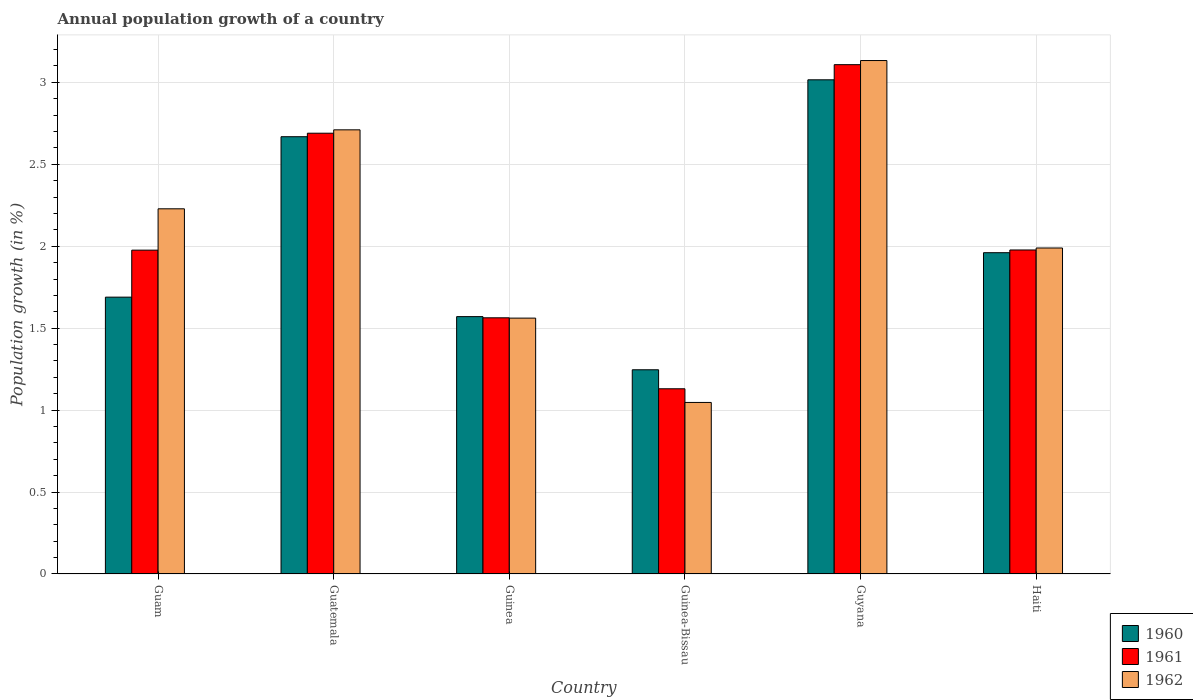How many different coloured bars are there?
Provide a short and direct response. 3. How many bars are there on the 2nd tick from the right?
Your response must be concise. 3. What is the label of the 5th group of bars from the left?
Provide a succinct answer. Guyana. In how many cases, is the number of bars for a given country not equal to the number of legend labels?
Your answer should be very brief. 0. What is the annual population growth in 1960 in Guinea?
Provide a short and direct response. 1.57. Across all countries, what is the maximum annual population growth in 1960?
Provide a short and direct response. 3.02. Across all countries, what is the minimum annual population growth in 1960?
Your response must be concise. 1.25. In which country was the annual population growth in 1962 maximum?
Offer a terse response. Guyana. In which country was the annual population growth in 1960 minimum?
Make the answer very short. Guinea-Bissau. What is the total annual population growth in 1960 in the graph?
Your answer should be compact. 12.15. What is the difference between the annual population growth in 1960 in Guam and that in Guyana?
Your response must be concise. -1.33. What is the difference between the annual population growth in 1962 in Guinea and the annual population growth in 1961 in Guyana?
Make the answer very short. -1.55. What is the average annual population growth in 1961 per country?
Give a very brief answer. 2.07. What is the difference between the annual population growth of/in 1962 and annual population growth of/in 1961 in Guatemala?
Provide a short and direct response. 0.02. What is the ratio of the annual population growth in 1962 in Guam to that in Haiti?
Offer a very short reply. 1.12. What is the difference between the highest and the second highest annual population growth in 1961?
Offer a terse response. -0.71. What is the difference between the highest and the lowest annual population growth in 1962?
Offer a terse response. 2.09. In how many countries, is the annual population growth in 1962 greater than the average annual population growth in 1962 taken over all countries?
Your answer should be compact. 3. What does the 3rd bar from the left in Guinea represents?
Make the answer very short. 1962. Is it the case that in every country, the sum of the annual population growth in 1961 and annual population growth in 1960 is greater than the annual population growth in 1962?
Ensure brevity in your answer.  Yes. What is the title of the graph?
Your answer should be very brief. Annual population growth of a country. What is the label or title of the X-axis?
Keep it short and to the point. Country. What is the label or title of the Y-axis?
Your response must be concise. Population growth (in %). What is the Population growth (in %) of 1960 in Guam?
Ensure brevity in your answer.  1.69. What is the Population growth (in %) in 1961 in Guam?
Keep it short and to the point. 1.98. What is the Population growth (in %) of 1962 in Guam?
Ensure brevity in your answer.  2.23. What is the Population growth (in %) in 1960 in Guatemala?
Offer a terse response. 2.67. What is the Population growth (in %) in 1961 in Guatemala?
Keep it short and to the point. 2.69. What is the Population growth (in %) of 1962 in Guatemala?
Your answer should be compact. 2.71. What is the Population growth (in %) in 1960 in Guinea?
Provide a short and direct response. 1.57. What is the Population growth (in %) of 1961 in Guinea?
Your answer should be compact. 1.56. What is the Population growth (in %) of 1962 in Guinea?
Offer a terse response. 1.56. What is the Population growth (in %) of 1960 in Guinea-Bissau?
Your response must be concise. 1.25. What is the Population growth (in %) of 1961 in Guinea-Bissau?
Give a very brief answer. 1.13. What is the Population growth (in %) of 1962 in Guinea-Bissau?
Provide a short and direct response. 1.05. What is the Population growth (in %) of 1960 in Guyana?
Your response must be concise. 3.02. What is the Population growth (in %) in 1961 in Guyana?
Ensure brevity in your answer.  3.11. What is the Population growth (in %) in 1962 in Guyana?
Your answer should be very brief. 3.13. What is the Population growth (in %) of 1960 in Haiti?
Make the answer very short. 1.96. What is the Population growth (in %) of 1961 in Haiti?
Provide a short and direct response. 1.98. What is the Population growth (in %) in 1962 in Haiti?
Give a very brief answer. 1.99. Across all countries, what is the maximum Population growth (in %) in 1960?
Provide a short and direct response. 3.02. Across all countries, what is the maximum Population growth (in %) of 1961?
Offer a terse response. 3.11. Across all countries, what is the maximum Population growth (in %) in 1962?
Provide a succinct answer. 3.13. Across all countries, what is the minimum Population growth (in %) of 1960?
Provide a succinct answer. 1.25. Across all countries, what is the minimum Population growth (in %) of 1961?
Give a very brief answer. 1.13. Across all countries, what is the minimum Population growth (in %) of 1962?
Your answer should be compact. 1.05. What is the total Population growth (in %) of 1960 in the graph?
Ensure brevity in your answer.  12.15. What is the total Population growth (in %) in 1961 in the graph?
Offer a very short reply. 12.44. What is the total Population growth (in %) in 1962 in the graph?
Keep it short and to the point. 12.67. What is the difference between the Population growth (in %) in 1960 in Guam and that in Guatemala?
Offer a very short reply. -0.98. What is the difference between the Population growth (in %) of 1961 in Guam and that in Guatemala?
Provide a succinct answer. -0.71. What is the difference between the Population growth (in %) of 1962 in Guam and that in Guatemala?
Your answer should be compact. -0.48. What is the difference between the Population growth (in %) in 1960 in Guam and that in Guinea?
Your answer should be compact. 0.12. What is the difference between the Population growth (in %) in 1961 in Guam and that in Guinea?
Your answer should be very brief. 0.41. What is the difference between the Population growth (in %) in 1962 in Guam and that in Guinea?
Offer a terse response. 0.67. What is the difference between the Population growth (in %) in 1960 in Guam and that in Guinea-Bissau?
Ensure brevity in your answer.  0.44. What is the difference between the Population growth (in %) in 1961 in Guam and that in Guinea-Bissau?
Keep it short and to the point. 0.85. What is the difference between the Population growth (in %) in 1962 in Guam and that in Guinea-Bissau?
Ensure brevity in your answer.  1.18. What is the difference between the Population growth (in %) in 1960 in Guam and that in Guyana?
Make the answer very short. -1.33. What is the difference between the Population growth (in %) of 1961 in Guam and that in Guyana?
Provide a short and direct response. -1.13. What is the difference between the Population growth (in %) of 1962 in Guam and that in Guyana?
Provide a short and direct response. -0.9. What is the difference between the Population growth (in %) in 1960 in Guam and that in Haiti?
Give a very brief answer. -0.27. What is the difference between the Population growth (in %) of 1961 in Guam and that in Haiti?
Your answer should be compact. -0. What is the difference between the Population growth (in %) in 1962 in Guam and that in Haiti?
Make the answer very short. 0.24. What is the difference between the Population growth (in %) in 1960 in Guatemala and that in Guinea?
Provide a succinct answer. 1.1. What is the difference between the Population growth (in %) in 1961 in Guatemala and that in Guinea?
Make the answer very short. 1.13. What is the difference between the Population growth (in %) of 1962 in Guatemala and that in Guinea?
Keep it short and to the point. 1.15. What is the difference between the Population growth (in %) of 1960 in Guatemala and that in Guinea-Bissau?
Make the answer very short. 1.42. What is the difference between the Population growth (in %) of 1961 in Guatemala and that in Guinea-Bissau?
Your answer should be compact. 1.56. What is the difference between the Population growth (in %) of 1962 in Guatemala and that in Guinea-Bissau?
Your answer should be compact. 1.66. What is the difference between the Population growth (in %) of 1960 in Guatemala and that in Guyana?
Keep it short and to the point. -0.35. What is the difference between the Population growth (in %) of 1961 in Guatemala and that in Guyana?
Ensure brevity in your answer.  -0.42. What is the difference between the Population growth (in %) in 1962 in Guatemala and that in Guyana?
Offer a very short reply. -0.42. What is the difference between the Population growth (in %) of 1960 in Guatemala and that in Haiti?
Provide a short and direct response. 0.71. What is the difference between the Population growth (in %) of 1961 in Guatemala and that in Haiti?
Ensure brevity in your answer.  0.71. What is the difference between the Population growth (in %) of 1962 in Guatemala and that in Haiti?
Your answer should be compact. 0.72. What is the difference between the Population growth (in %) in 1960 in Guinea and that in Guinea-Bissau?
Your answer should be very brief. 0.32. What is the difference between the Population growth (in %) of 1961 in Guinea and that in Guinea-Bissau?
Offer a terse response. 0.43. What is the difference between the Population growth (in %) of 1962 in Guinea and that in Guinea-Bissau?
Ensure brevity in your answer.  0.51. What is the difference between the Population growth (in %) of 1960 in Guinea and that in Guyana?
Give a very brief answer. -1.45. What is the difference between the Population growth (in %) of 1961 in Guinea and that in Guyana?
Ensure brevity in your answer.  -1.54. What is the difference between the Population growth (in %) in 1962 in Guinea and that in Guyana?
Give a very brief answer. -1.57. What is the difference between the Population growth (in %) of 1960 in Guinea and that in Haiti?
Provide a succinct answer. -0.39. What is the difference between the Population growth (in %) in 1961 in Guinea and that in Haiti?
Offer a very short reply. -0.41. What is the difference between the Population growth (in %) of 1962 in Guinea and that in Haiti?
Provide a succinct answer. -0.43. What is the difference between the Population growth (in %) of 1960 in Guinea-Bissau and that in Guyana?
Your answer should be compact. -1.77. What is the difference between the Population growth (in %) of 1961 in Guinea-Bissau and that in Guyana?
Provide a short and direct response. -1.98. What is the difference between the Population growth (in %) of 1962 in Guinea-Bissau and that in Guyana?
Keep it short and to the point. -2.09. What is the difference between the Population growth (in %) of 1960 in Guinea-Bissau and that in Haiti?
Offer a very short reply. -0.71. What is the difference between the Population growth (in %) in 1961 in Guinea-Bissau and that in Haiti?
Your response must be concise. -0.85. What is the difference between the Population growth (in %) in 1962 in Guinea-Bissau and that in Haiti?
Make the answer very short. -0.94. What is the difference between the Population growth (in %) in 1960 in Guyana and that in Haiti?
Your answer should be very brief. 1.06. What is the difference between the Population growth (in %) of 1961 in Guyana and that in Haiti?
Your response must be concise. 1.13. What is the difference between the Population growth (in %) of 1962 in Guyana and that in Haiti?
Your answer should be very brief. 1.14. What is the difference between the Population growth (in %) of 1960 in Guam and the Population growth (in %) of 1961 in Guatemala?
Your response must be concise. -1. What is the difference between the Population growth (in %) of 1960 in Guam and the Population growth (in %) of 1962 in Guatemala?
Your answer should be very brief. -1.02. What is the difference between the Population growth (in %) of 1961 in Guam and the Population growth (in %) of 1962 in Guatemala?
Your answer should be very brief. -0.73. What is the difference between the Population growth (in %) in 1960 in Guam and the Population growth (in %) in 1961 in Guinea?
Offer a very short reply. 0.13. What is the difference between the Population growth (in %) in 1960 in Guam and the Population growth (in %) in 1962 in Guinea?
Ensure brevity in your answer.  0.13. What is the difference between the Population growth (in %) in 1961 in Guam and the Population growth (in %) in 1962 in Guinea?
Your answer should be compact. 0.41. What is the difference between the Population growth (in %) of 1960 in Guam and the Population growth (in %) of 1961 in Guinea-Bissau?
Make the answer very short. 0.56. What is the difference between the Population growth (in %) in 1960 in Guam and the Population growth (in %) in 1962 in Guinea-Bissau?
Give a very brief answer. 0.64. What is the difference between the Population growth (in %) in 1961 in Guam and the Population growth (in %) in 1962 in Guinea-Bissau?
Give a very brief answer. 0.93. What is the difference between the Population growth (in %) of 1960 in Guam and the Population growth (in %) of 1961 in Guyana?
Provide a succinct answer. -1.42. What is the difference between the Population growth (in %) of 1960 in Guam and the Population growth (in %) of 1962 in Guyana?
Offer a very short reply. -1.44. What is the difference between the Population growth (in %) of 1961 in Guam and the Population growth (in %) of 1962 in Guyana?
Your answer should be compact. -1.16. What is the difference between the Population growth (in %) of 1960 in Guam and the Population growth (in %) of 1961 in Haiti?
Provide a short and direct response. -0.29. What is the difference between the Population growth (in %) of 1960 in Guam and the Population growth (in %) of 1962 in Haiti?
Keep it short and to the point. -0.3. What is the difference between the Population growth (in %) in 1961 in Guam and the Population growth (in %) in 1962 in Haiti?
Make the answer very short. -0.01. What is the difference between the Population growth (in %) of 1960 in Guatemala and the Population growth (in %) of 1961 in Guinea?
Provide a succinct answer. 1.11. What is the difference between the Population growth (in %) in 1960 in Guatemala and the Population growth (in %) in 1962 in Guinea?
Provide a succinct answer. 1.11. What is the difference between the Population growth (in %) in 1961 in Guatemala and the Population growth (in %) in 1962 in Guinea?
Your answer should be compact. 1.13. What is the difference between the Population growth (in %) of 1960 in Guatemala and the Population growth (in %) of 1961 in Guinea-Bissau?
Your answer should be very brief. 1.54. What is the difference between the Population growth (in %) in 1960 in Guatemala and the Population growth (in %) in 1962 in Guinea-Bissau?
Give a very brief answer. 1.62. What is the difference between the Population growth (in %) in 1961 in Guatemala and the Population growth (in %) in 1962 in Guinea-Bissau?
Make the answer very short. 1.64. What is the difference between the Population growth (in %) in 1960 in Guatemala and the Population growth (in %) in 1961 in Guyana?
Provide a short and direct response. -0.44. What is the difference between the Population growth (in %) in 1960 in Guatemala and the Population growth (in %) in 1962 in Guyana?
Offer a very short reply. -0.46. What is the difference between the Population growth (in %) of 1961 in Guatemala and the Population growth (in %) of 1962 in Guyana?
Provide a short and direct response. -0.44. What is the difference between the Population growth (in %) in 1960 in Guatemala and the Population growth (in %) in 1961 in Haiti?
Your answer should be very brief. 0.69. What is the difference between the Population growth (in %) in 1960 in Guatemala and the Population growth (in %) in 1962 in Haiti?
Your answer should be very brief. 0.68. What is the difference between the Population growth (in %) of 1961 in Guatemala and the Population growth (in %) of 1962 in Haiti?
Keep it short and to the point. 0.7. What is the difference between the Population growth (in %) in 1960 in Guinea and the Population growth (in %) in 1961 in Guinea-Bissau?
Provide a short and direct response. 0.44. What is the difference between the Population growth (in %) in 1960 in Guinea and the Population growth (in %) in 1962 in Guinea-Bissau?
Provide a short and direct response. 0.52. What is the difference between the Population growth (in %) of 1961 in Guinea and the Population growth (in %) of 1962 in Guinea-Bissau?
Ensure brevity in your answer.  0.52. What is the difference between the Population growth (in %) in 1960 in Guinea and the Population growth (in %) in 1961 in Guyana?
Provide a succinct answer. -1.54. What is the difference between the Population growth (in %) of 1960 in Guinea and the Population growth (in %) of 1962 in Guyana?
Ensure brevity in your answer.  -1.56. What is the difference between the Population growth (in %) of 1961 in Guinea and the Population growth (in %) of 1962 in Guyana?
Your answer should be very brief. -1.57. What is the difference between the Population growth (in %) of 1960 in Guinea and the Population growth (in %) of 1961 in Haiti?
Your answer should be very brief. -0.41. What is the difference between the Population growth (in %) in 1960 in Guinea and the Population growth (in %) in 1962 in Haiti?
Your answer should be compact. -0.42. What is the difference between the Population growth (in %) in 1961 in Guinea and the Population growth (in %) in 1962 in Haiti?
Provide a short and direct response. -0.43. What is the difference between the Population growth (in %) of 1960 in Guinea-Bissau and the Population growth (in %) of 1961 in Guyana?
Offer a very short reply. -1.86. What is the difference between the Population growth (in %) in 1960 in Guinea-Bissau and the Population growth (in %) in 1962 in Guyana?
Your answer should be very brief. -1.89. What is the difference between the Population growth (in %) in 1961 in Guinea-Bissau and the Population growth (in %) in 1962 in Guyana?
Provide a succinct answer. -2. What is the difference between the Population growth (in %) of 1960 in Guinea-Bissau and the Population growth (in %) of 1961 in Haiti?
Give a very brief answer. -0.73. What is the difference between the Population growth (in %) in 1960 in Guinea-Bissau and the Population growth (in %) in 1962 in Haiti?
Your answer should be compact. -0.74. What is the difference between the Population growth (in %) in 1961 in Guinea-Bissau and the Population growth (in %) in 1962 in Haiti?
Offer a terse response. -0.86. What is the difference between the Population growth (in %) in 1960 in Guyana and the Population growth (in %) in 1961 in Haiti?
Provide a short and direct response. 1.04. What is the difference between the Population growth (in %) in 1960 in Guyana and the Population growth (in %) in 1962 in Haiti?
Provide a succinct answer. 1.03. What is the difference between the Population growth (in %) of 1961 in Guyana and the Population growth (in %) of 1962 in Haiti?
Your answer should be very brief. 1.12. What is the average Population growth (in %) in 1960 per country?
Offer a very short reply. 2.03. What is the average Population growth (in %) of 1961 per country?
Give a very brief answer. 2.07. What is the average Population growth (in %) of 1962 per country?
Provide a succinct answer. 2.11. What is the difference between the Population growth (in %) of 1960 and Population growth (in %) of 1961 in Guam?
Ensure brevity in your answer.  -0.29. What is the difference between the Population growth (in %) in 1960 and Population growth (in %) in 1962 in Guam?
Give a very brief answer. -0.54. What is the difference between the Population growth (in %) in 1961 and Population growth (in %) in 1962 in Guam?
Make the answer very short. -0.25. What is the difference between the Population growth (in %) in 1960 and Population growth (in %) in 1961 in Guatemala?
Your answer should be very brief. -0.02. What is the difference between the Population growth (in %) in 1960 and Population growth (in %) in 1962 in Guatemala?
Make the answer very short. -0.04. What is the difference between the Population growth (in %) of 1961 and Population growth (in %) of 1962 in Guatemala?
Your answer should be very brief. -0.02. What is the difference between the Population growth (in %) in 1960 and Population growth (in %) in 1961 in Guinea?
Your answer should be very brief. 0.01. What is the difference between the Population growth (in %) of 1960 and Population growth (in %) of 1962 in Guinea?
Offer a terse response. 0.01. What is the difference between the Population growth (in %) in 1961 and Population growth (in %) in 1962 in Guinea?
Provide a short and direct response. 0. What is the difference between the Population growth (in %) of 1960 and Population growth (in %) of 1961 in Guinea-Bissau?
Your answer should be compact. 0.12. What is the difference between the Population growth (in %) in 1960 and Population growth (in %) in 1962 in Guinea-Bissau?
Ensure brevity in your answer.  0.2. What is the difference between the Population growth (in %) of 1961 and Population growth (in %) of 1962 in Guinea-Bissau?
Make the answer very short. 0.08. What is the difference between the Population growth (in %) of 1960 and Population growth (in %) of 1961 in Guyana?
Provide a succinct answer. -0.09. What is the difference between the Population growth (in %) in 1960 and Population growth (in %) in 1962 in Guyana?
Your answer should be very brief. -0.12. What is the difference between the Population growth (in %) of 1961 and Population growth (in %) of 1962 in Guyana?
Keep it short and to the point. -0.03. What is the difference between the Population growth (in %) in 1960 and Population growth (in %) in 1961 in Haiti?
Offer a terse response. -0.02. What is the difference between the Population growth (in %) of 1960 and Population growth (in %) of 1962 in Haiti?
Offer a terse response. -0.03. What is the difference between the Population growth (in %) in 1961 and Population growth (in %) in 1962 in Haiti?
Offer a very short reply. -0.01. What is the ratio of the Population growth (in %) of 1960 in Guam to that in Guatemala?
Give a very brief answer. 0.63. What is the ratio of the Population growth (in %) in 1961 in Guam to that in Guatemala?
Give a very brief answer. 0.73. What is the ratio of the Population growth (in %) of 1962 in Guam to that in Guatemala?
Give a very brief answer. 0.82. What is the ratio of the Population growth (in %) of 1960 in Guam to that in Guinea?
Ensure brevity in your answer.  1.08. What is the ratio of the Population growth (in %) in 1961 in Guam to that in Guinea?
Provide a succinct answer. 1.26. What is the ratio of the Population growth (in %) in 1962 in Guam to that in Guinea?
Your response must be concise. 1.43. What is the ratio of the Population growth (in %) of 1960 in Guam to that in Guinea-Bissau?
Provide a succinct answer. 1.36. What is the ratio of the Population growth (in %) in 1961 in Guam to that in Guinea-Bissau?
Your response must be concise. 1.75. What is the ratio of the Population growth (in %) of 1962 in Guam to that in Guinea-Bissau?
Provide a short and direct response. 2.13. What is the ratio of the Population growth (in %) of 1960 in Guam to that in Guyana?
Provide a short and direct response. 0.56. What is the ratio of the Population growth (in %) in 1961 in Guam to that in Guyana?
Provide a succinct answer. 0.64. What is the ratio of the Population growth (in %) in 1962 in Guam to that in Guyana?
Offer a terse response. 0.71. What is the ratio of the Population growth (in %) in 1960 in Guam to that in Haiti?
Provide a succinct answer. 0.86. What is the ratio of the Population growth (in %) of 1961 in Guam to that in Haiti?
Provide a succinct answer. 1. What is the ratio of the Population growth (in %) of 1962 in Guam to that in Haiti?
Provide a succinct answer. 1.12. What is the ratio of the Population growth (in %) of 1960 in Guatemala to that in Guinea?
Make the answer very short. 1.7. What is the ratio of the Population growth (in %) in 1961 in Guatemala to that in Guinea?
Provide a succinct answer. 1.72. What is the ratio of the Population growth (in %) of 1962 in Guatemala to that in Guinea?
Provide a short and direct response. 1.74. What is the ratio of the Population growth (in %) in 1960 in Guatemala to that in Guinea-Bissau?
Offer a very short reply. 2.14. What is the ratio of the Population growth (in %) of 1961 in Guatemala to that in Guinea-Bissau?
Make the answer very short. 2.38. What is the ratio of the Population growth (in %) in 1962 in Guatemala to that in Guinea-Bissau?
Offer a very short reply. 2.59. What is the ratio of the Population growth (in %) of 1960 in Guatemala to that in Guyana?
Offer a terse response. 0.88. What is the ratio of the Population growth (in %) of 1961 in Guatemala to that in Guyana?
Your answer should be compact. 0.87. What is the ratio of the Population growth (in %) of 1962 in Guatemala to that in Guyana?
Your answer should be very brief. 0.87. What is the ratio of the Population growth (in %) of 1960 in Guatemala to that in Haiti?
Provide a short and direct response. 1.36. What is the ratio of the Population growth (in %) in 1961 in Guatemala to that in Haiti?
Provide a succinct answer. 1.36. What is the ratio of the Population growth (in %) of 1962 in Guatemala to that in Haiti?
Give a very brief answer. 1.36. What is the ratio of the Population growth (in %) in 1960 in Guinea to that in Guinea-Bissau?
Offer a terse response. 1.26. What is the ratio of the Population growth (in %) in 1961 in Guinea to that in Guinea-Bissau?
Ensure brevity in your answer.  1.38. What is the ratio of the Population growth (in %) of 1962 in Guinea to that in Guinea-Bissau?
Give a very brief answer. 1.49. What is the ratio of the Population growth (in %) of 1960 in Guinea to that in Guyana?
Ensure brevity in your answer.  0.52. What is the ratio of the Population growth (in %) of 1961 in Guinea to that in Guyana?
Offer a terse response. 0.5. What is the ratio of the Population growth (in %) of 1962 in Guinea to that in Guyana?
Your response must be concise. 0.5. What is the ratio of the Population growth (in %) of 1960 in Guinea to that in Haiti?
Provide a short and direct response. 0.8. What is the ratio of the Population growth (in %) of 1961 in Guinea to that in Haiti?
Offer a very short reply. 0.79. What is the ratio of the Population growth (in %) of 1962 in Guinea to that in Haiti?
Make the answer very short. 0.78. What is the ratio of the Population growth (in %) in 1960 in Guinea-Bissau to that in Guyana?
Ensure brevity in your answer.  0.41. What is the ratio of the Population growth (in %) of 1961 in Guinea-Bissau to that in Guyana?
Give a very brief answer. 0.36. What is the ratio of the Population growth (in %) of 1962 in Guinea-Bissau to that in Guyana?
Make the answer very short. 0.33. What is the ratio of the Population growth (in %) of 1960 in Guinea-Bissau to that in Haiti?
Ensure brevity in your answer.  0.64. What is the ratio of the Population growth (in %) of 1961 in Guinea-Bissau to that in Haiti?
Make the answer very short. 0.57. What is the ratio of the Population growth (in %) of 1962 in Guinea-Bissau to that in Haiti?
Offer a very short reply. 0.53. What is the ratio of the Population growth (in %) of 1960 in Guyana to that in Haiti?
Keep it short and to the point. 1.54. What is the ratio of the Population growth (in %) in 1961 in Guyana to that in Haiti?
Ensure brevity in your answer.  1.57. What is the ratio of the Population growth (in %) of 1962 in Guyana to that in Haiti?
Provide a short and direct response. 1.57. What is the difference between the highest and the second highest Population growth (in %) of 1960?
Offer a very short reply. 0.35. What is the difference between the highest and the second highest Population growth (in %) of 1961?
Give a very brief answer. 0.42. What is the difference between the highest and the second highest Population growth (in %) in 1962?
Offer a terse response. 0.42. What is the difference between the highest and the lowest Population growth (in %) in 1960?
Provide a short and direct response. 1.77. What is the difference between the highest and the lowest Population growth (in %) of 1961?
Give a very brief answer. 1.98. What is the difference between the highest and the lowest Population growth (in %) in 1962?
Make the answer very short. 2.09. 